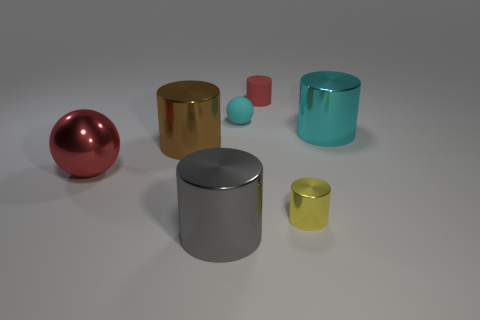What is the size of the object that is both in front of the cyan rubber sphere and behind the large brown cylinder?
Make the answer very short. Large. The red metallic object that is the same size as the brown metal cylinder is what shape?
Ensure brevity in your answer.  Sphere. There is a ball that is in front of the tiny cyan matte ball; is there a yellow thing that is left of it?
Keep it short and to the point. No. There is another small object that is the same shape as the red metal object; what color is it?
Ensure brevity in your answer.  Cyan. There is a ball that is behind the big cyan metallic cylinder; does it have the same color as the tiny rubber cylinder?
Give a very brief answer. No. How many objects are either red objects in front of the small red object or yellow metallic spheres?
Your answer should be very brief. 1. What material is the tiny cylinder behind the large thing right of the large cylinder that is in front of the red shiny sphere?
Give a very brief answer. Rubber. Is the number of small cyan matte spheres in front of the cyan matte thing greater than the number of tiny yellow shiny cylinders in front of the large brown thing?
Give a very brief answer. No. What number of balls are either yellow things or small cyan rubber objects?
Ensure brevity in your answer.  1. How many large red shiny balls are behind the ball in front of the large thing that is to the right of the tiny matte ball?
Ensure brevity in your answer.  0. 